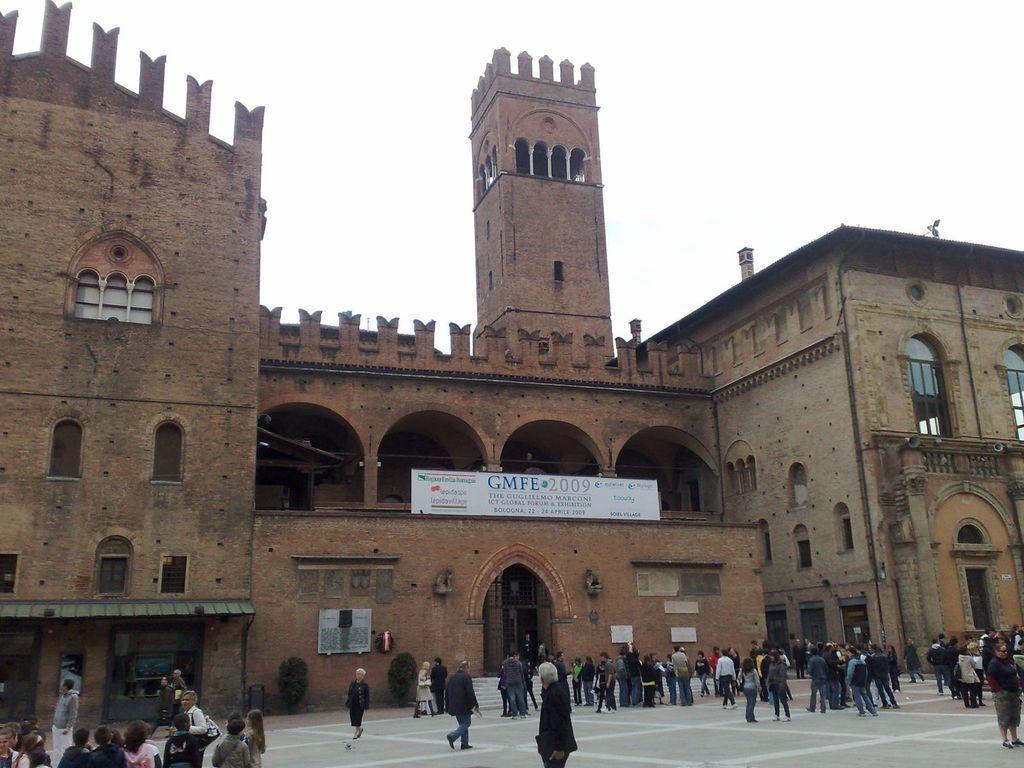Describe this image in one or two sentences. In this picture I can see buildings and a white color board. I can also see people standing on the ground. Here I can see trees. In the background I can see the sky. 